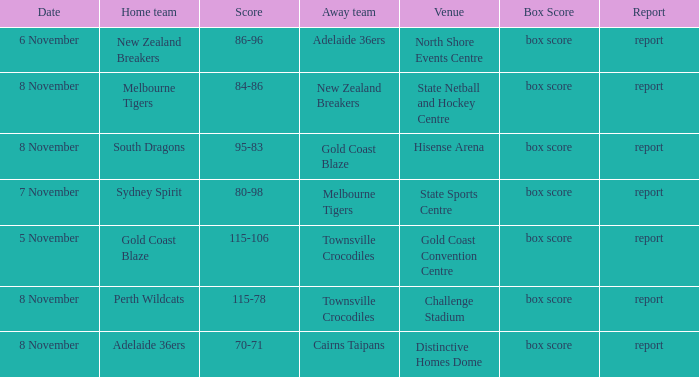What was the box score during a game that had a score of 86-96? Box score. 